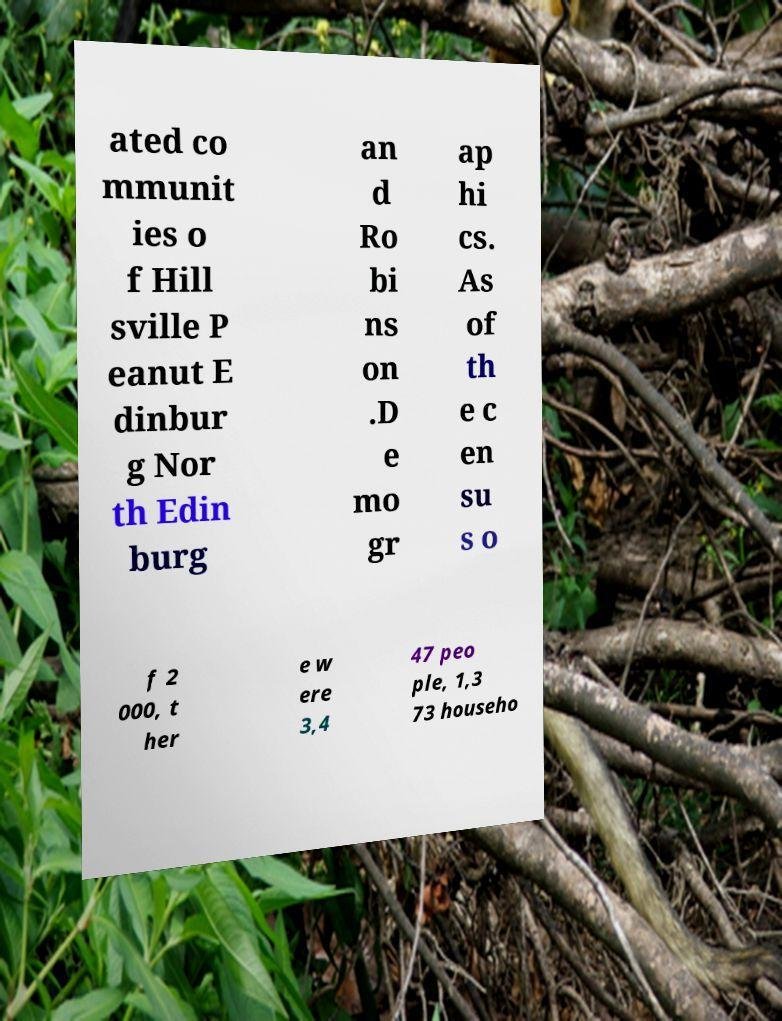There's text embedded in this image that I need extracted. Can you transcribe it verbatim? ated co mmunit ies o f Hill sville P eanut E dinbur g Nor th Edin burg an d Ro bi ns on .D e mo gr ap hi cs. As of th e c en su s o f 2 000, t her e w ere 3,4 47 peo ple, 1,3 73 househo 